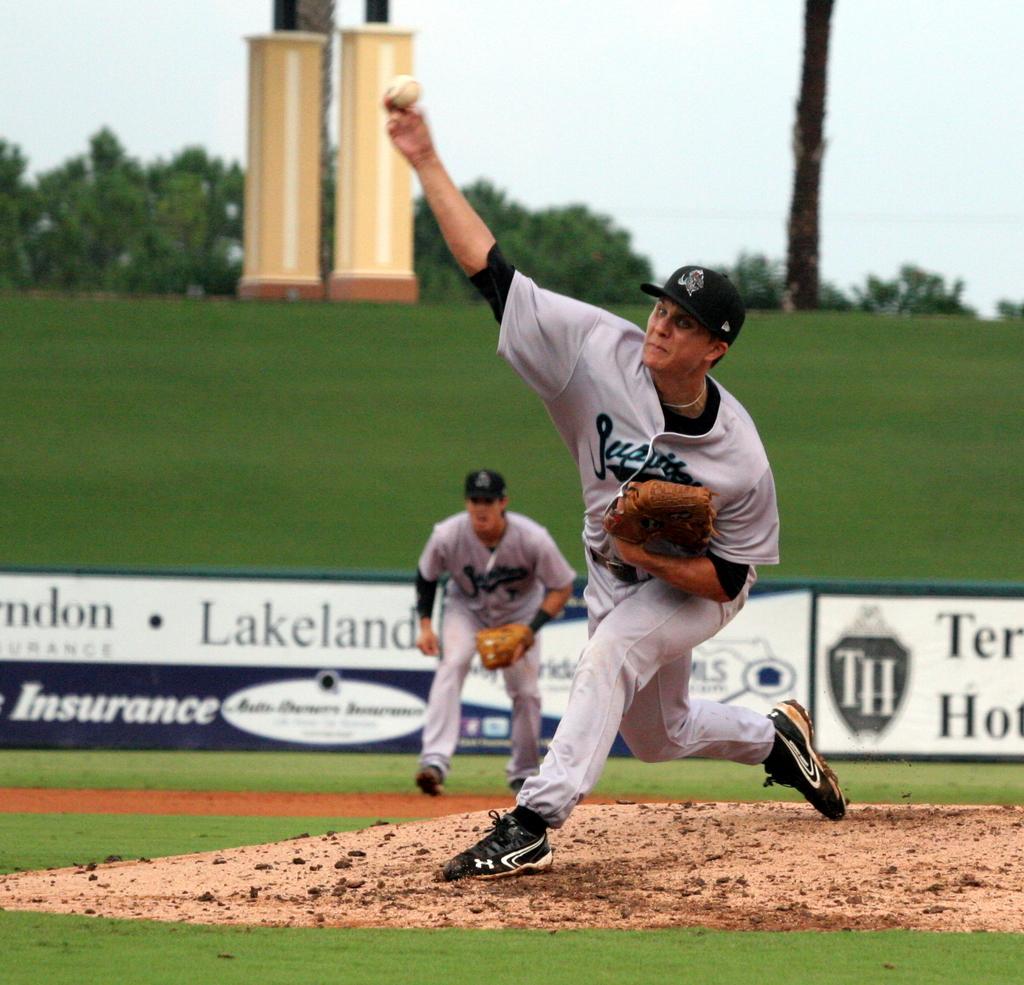What type of coverage is advertised in the back on the sign?
Give a very brief answer. Insurance. 